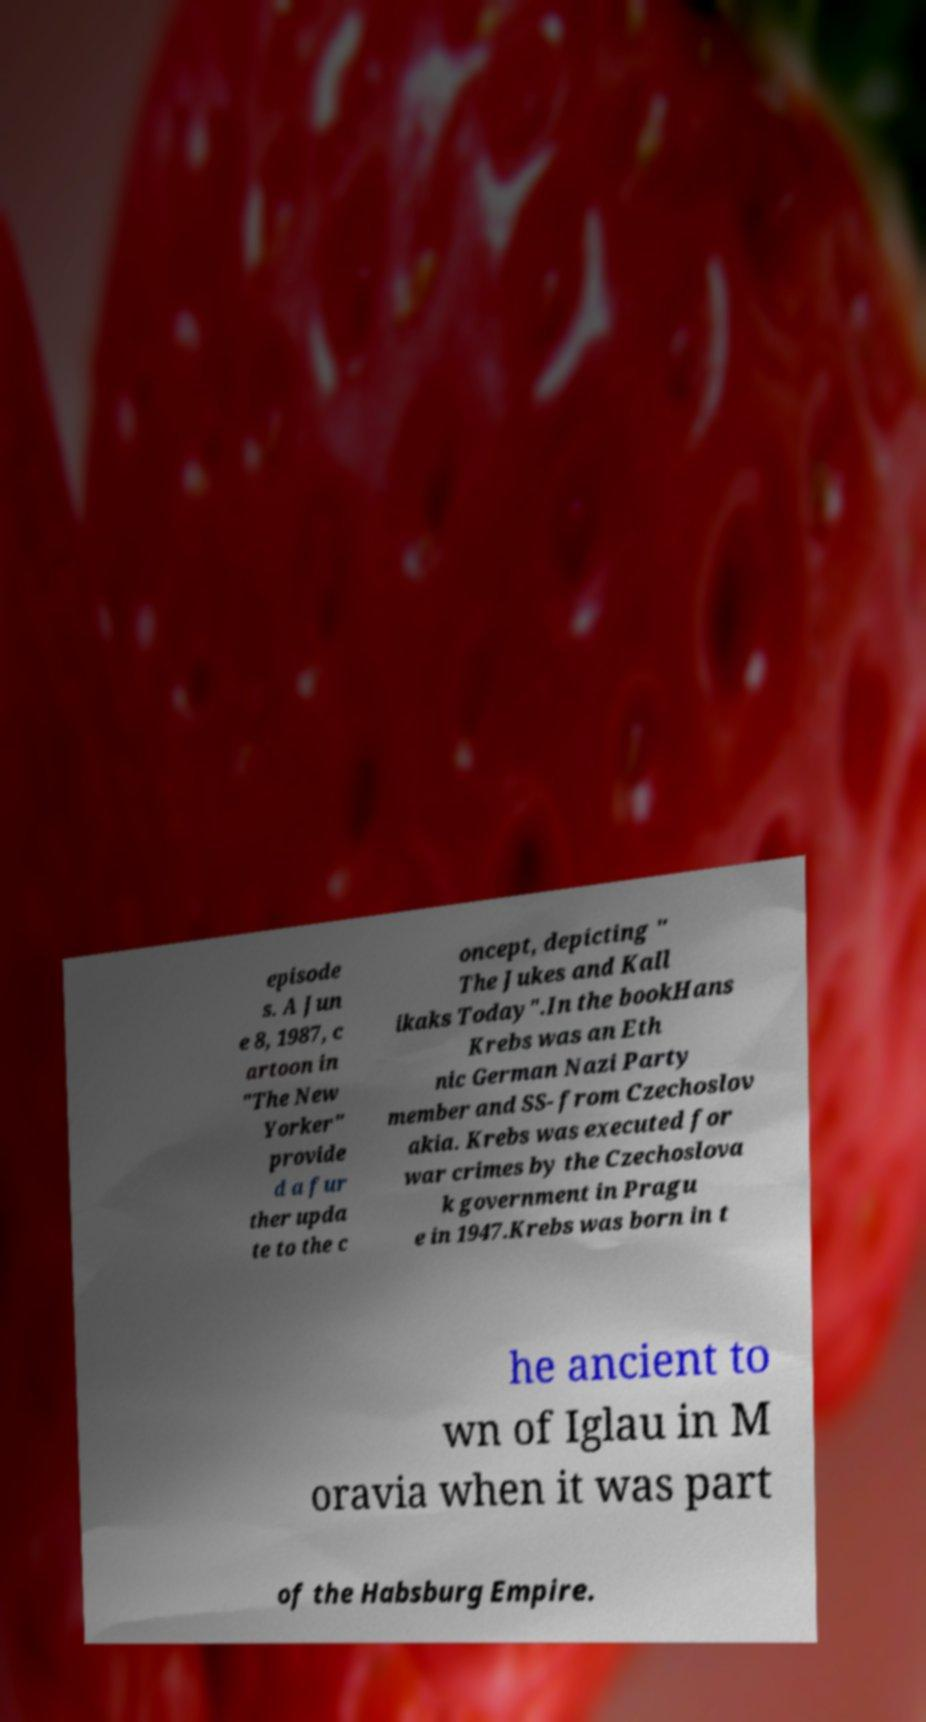Please read and relay the text visible in this image. What does it say? episode s. A Jun e 8, 1987, c artoon in "The New Yorker" provide d a fur ther upda te to the c oncept, depicting " The Jukes and Kall ikaks Today".In the bookHans Krebs was an Eth nic German Nazi Party member and SS- from Czechoslov akia. Krebs was executed for war crimes by the Czechoslova k government in Pragu e in 1947.Krebs was born in t he ancient to wn of Iglau in M oravia when it was part of the Habsburg Empire. 